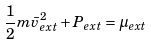<formula> <loc_0><loc_0><loc_500><loc_500>\frac { 1 } { 2 } m \bar { v } _ { e x t } ^ { 2 } + P _ { e x t } = \mu _ { e x t }</formula> 